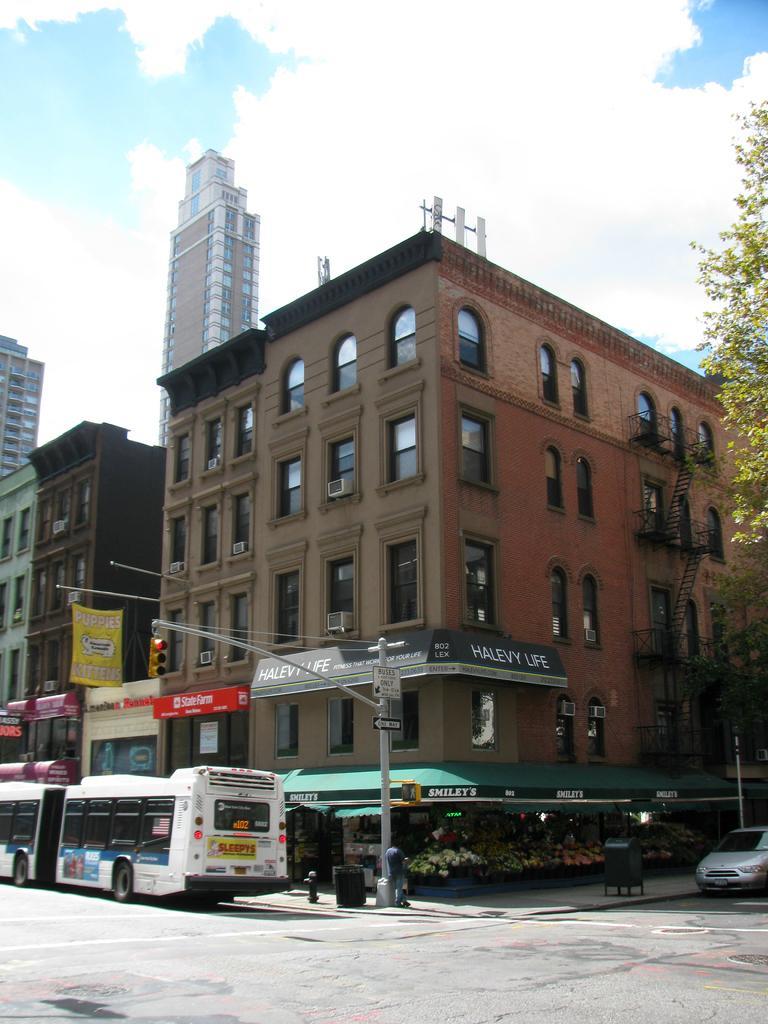Can you describe this image briefly? In this image, we can see a building, street light, board, trees, buses, window, tower. At the top, we can see a sky which is a bit cloudy, at the bottom, we can see some vehicles and a road. 